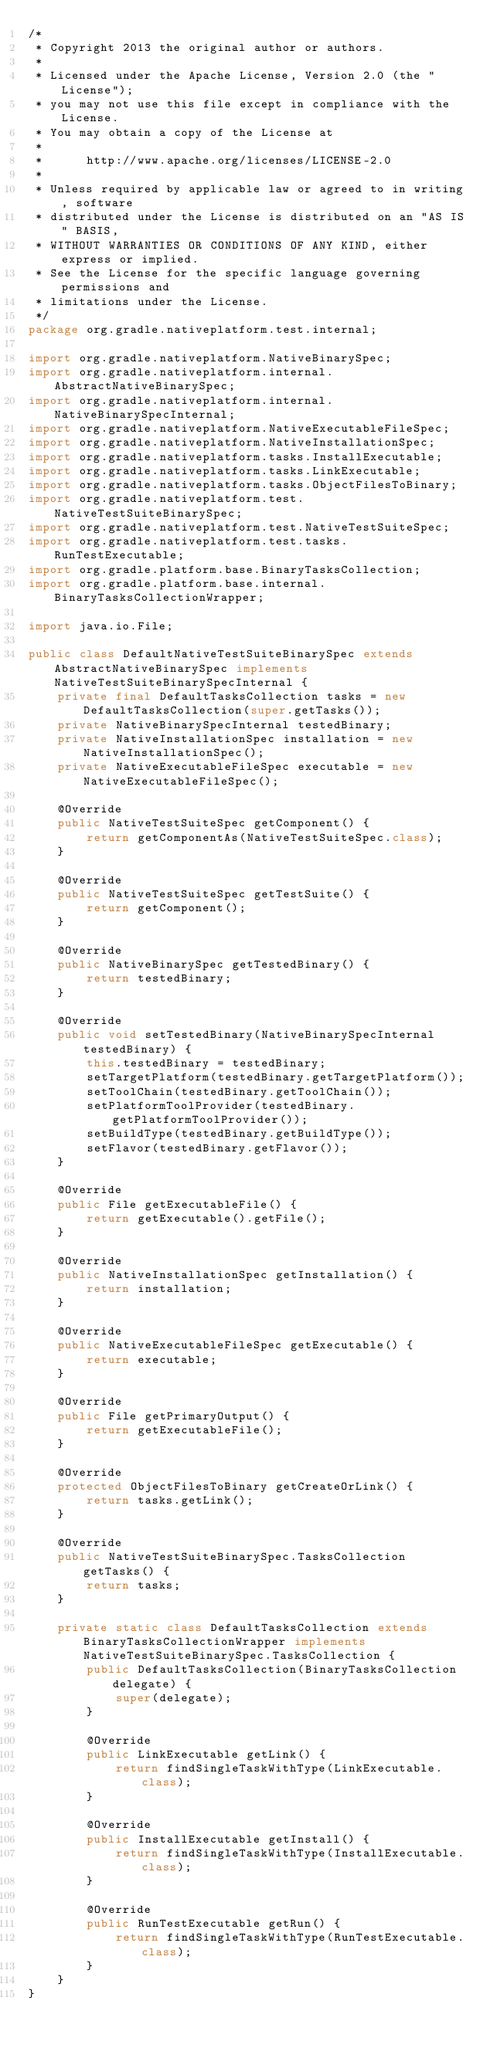Convert code to text. <code><loc_0><loc_0><loc_500><loc_500><_Java_>/*
 * Copyright 2013 the original author or authors.
 *
 * Licensed under the Apache License, Version 2.0 (the "License");
 * you may not use this file except in compliance with the License.
 * You may obtain a copy of the License at
 *
 *      http://www.apache.org/licenses/LICENSE-2.0
 *
 * Unless required by applicable law or agreed to in writing, software
 * distributed under the License is distributed on an "AS IS" BASIS,
 * WITHOUT WARRANTIES OR CONDITIONS OF ANY KIND, either express or implied.
 * See the License for the specific language governing permissions and
 * limitations under the License.
 */
package org.gradle.nativeplatform.test.internal;

import org.gradle.nativeplatform.NativeBinarySpec;
import org.gradle.nativeplatform.internal.AbstractNativeBinarySpec;
import org.gradle.nativeplatform.internal.NativeBinarySpecInternal;
import org.gradle.nativeplatform.NativeExecutableFileSpec;
import org.gradle.nativeplatform.NativeInstallationSpec;
import org.gradle.nativeplatform.tasks.InstallExecutable;
import org.gradle.nativeplatform.tasks.LinkExecutable;
import org.gradle.nativeplatform.tasks.ObjectFilesToBinary;
import org.gradle.nativeplatform.test.NativeTestSuiteBinarySpec;
import org.gradle.nativeplatform.test.NativeTestSuiteSpec;
import org.gradle.nativeplatform.test.tasks.RunTestExecutable;
import org.gradle.platform.base.BinaryTasksCollection;
import org.gradle.platform.base.internal.BinaryTasksCollectionWrapper;

import java.io.File;

public class DefaultNativeTestSuiteBinarySpec extends AbstractNativeBinarySpec implements NativeTestSuiteBinarySpecInternal {
    private final DefaultTasksCollection tasks = new DefaultTasksCollection(super.getTasks());
    private NativeBinarySpecInternal testedBinary;
    private NativeInstallationSpec installation = new NativeInstallationSpec();
    private NativeExecutableFileSpec executable = new NativeExecutableFileSpec();

    @Override
    public NativeTestSuiteSpec getComponent() {
        return getComponentAs(NativeTestSuiteSpec.class);
    }

    @Override
    public NativeTestSuiteSpec getTestSuite() {
        return getComponent();
    }

    @Override
    public NativeBinarySpec getTestedBinary() {
        return testedBinary;
    }

    @Override
    public void setTestedBinary(NativeBinarySpecInternal testedBinary) {
        this.testedBinary = testedBinary;
        setTargetPlatform(testedBinary.getTargetPlatform());
        setToolChain(testedBinary.getToolChain());
        setPlatformToolProvider(testedBinary.getPlatformToolProvider());
        setBuildType(testedBinary.getBuildType());
        setFlavor(testedBinary.getFlavor());
    }

    @Override
    public File getExecutableFile() {
        return getExecutable().getFile();
    }

    @Override
    public NativeInstallationSpec getInstallation() {
        return installation;
    }

    @Override
    public NativeExecutableFileSpec getExecutable() {
        return executable;
    }

    @Override
    public File getPrimaryOutput() {
        return getExecutableFile();
    }

    @Override
    protected ObjectFilesToBinary getCreateOrLink() {
        return tasks.getLink();
    }

    @Override
    public NativeTestSuiteBinarySpec.TasksCollection getTasks() {
        return tasks;
    }

    private static class DefaultTasksCollection extends BinaryTasksCollectionWrapper implements NativeTestSuiteBinarySpec.TasksCollection {
        public DefaultTasksCollection(BinaryTasksCollection delegate) {
            super(delegate);
        }

        @Override
        public LinkExecutable getLink() {
            return findSingleTaskWithType(LinkExecutable.class);
        }

        @Override
        public InstallExecutable getInstall() {
            return findSingleTaskWithType(InstallExecutable.class);
        }

        @Override
        public RunTestExecutable getRun() {
            return findSingleTaskWithType(RunTestExecutable.class);
        }
    }
}
</code> 